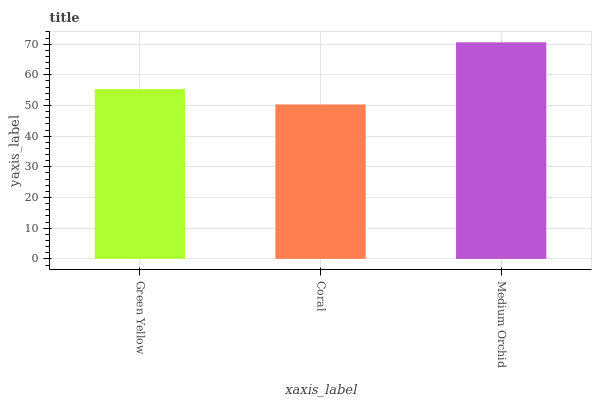Is Coral the minimum?
Answer yes or no. Yes. Is Medium Orchid the maximum?
Answer yes or no. Yes. Is Medium Orchid the minimum?
Answer yes or no. No. Is Coral the maximum?
Answer yes or no. No. Is Medium Orchid greater than Coral?
Answer yes or no. Yes. Is Coral less than Medium Orchid?
Answer yes or no. Yes. Is Coral greater than Medium Orchid?
Answer yes or no. No. Is Medium Orchid less than Coral?
Answer yes or no. No. Is Green Yellow the high median?
Answer yes or no. Yes. Is Green Yellow the low median?
Answer yes or no. Yes. Is Coral the high median?
Answer yes or no. No. Is Medium Orchid the low median?
Answer yes or no. No. 